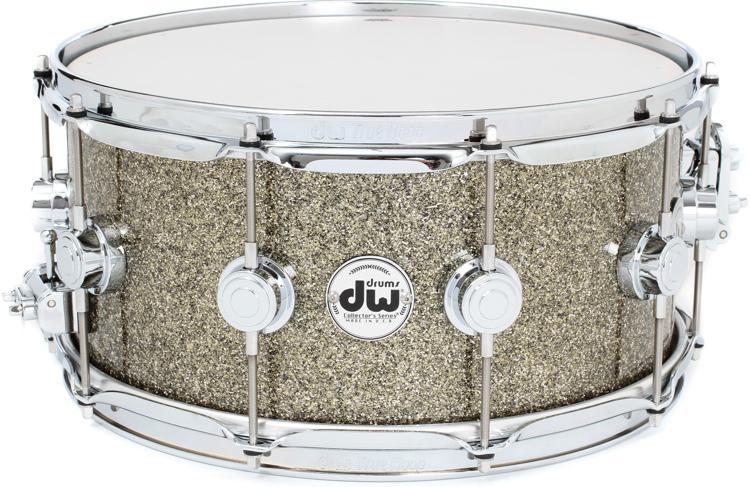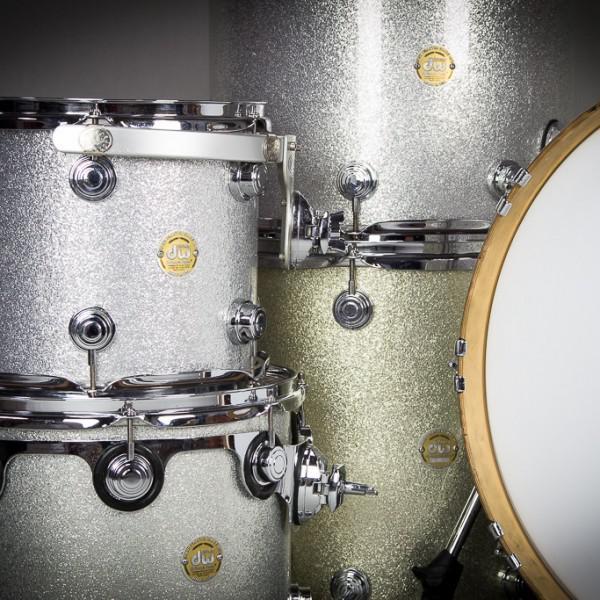The first image is the image on the left, the second image is the image on the right. Assess this claim about the two images: "The right image features one drum with a concave top on a pivoting black stand, and the left image includes at least one cylindrical flat-topped drum displayed sitting on a flat side.". Correct or not? Answer yes or no. No. The first image is the image on the left, the second image is the image on the right. Considering the images on both sides, is "There are drums stacked on top of one another." valid? Answer yes or no. Yes. 